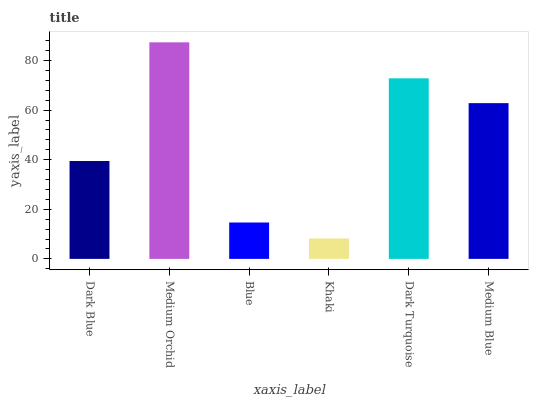Is Khaki the minimum?
Answer yes or no. Yes. Is Medium Orchid the maximum?
Answer yes or no. Yes. Is Blue the minimum?
Answer yes or no. No. Is Blue the maximum?
Answer yes or no. No. Is Medium Orchid greater than Blue?
Answer yes or no. Yes. Is Blue less than Medium Orchid?
Answer yes or no. Yes. Is Blue greater than Medium Orchid?
Answer yes or no. No. Is Medium Orchid less than Blue?
Answer yes or no. No. Is Medium Blue the high median?
Answer yes or no. Yes. Is Dark Blue the low median?
Answer yes or no. Yes. Is Medium Orchid the high median?
Answer yes or no. No. Is Dark Turquoise the low median?
Answer yes or no. No. 